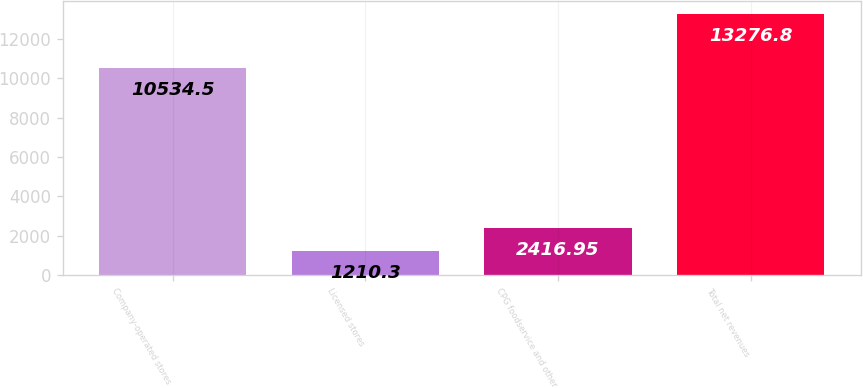Convert chart. <chart><loc_0><loc_0><loc_500><loc_500><bar_chart><fcel>Company-operated stores<fcel>Licensed stores<fcel>CPG foodservice and other<fcel>Total net revenues<nl><fcel>10534.5<fcel>1210.3<fcel>2416.95<fcel>13276.8<nl></chart> 